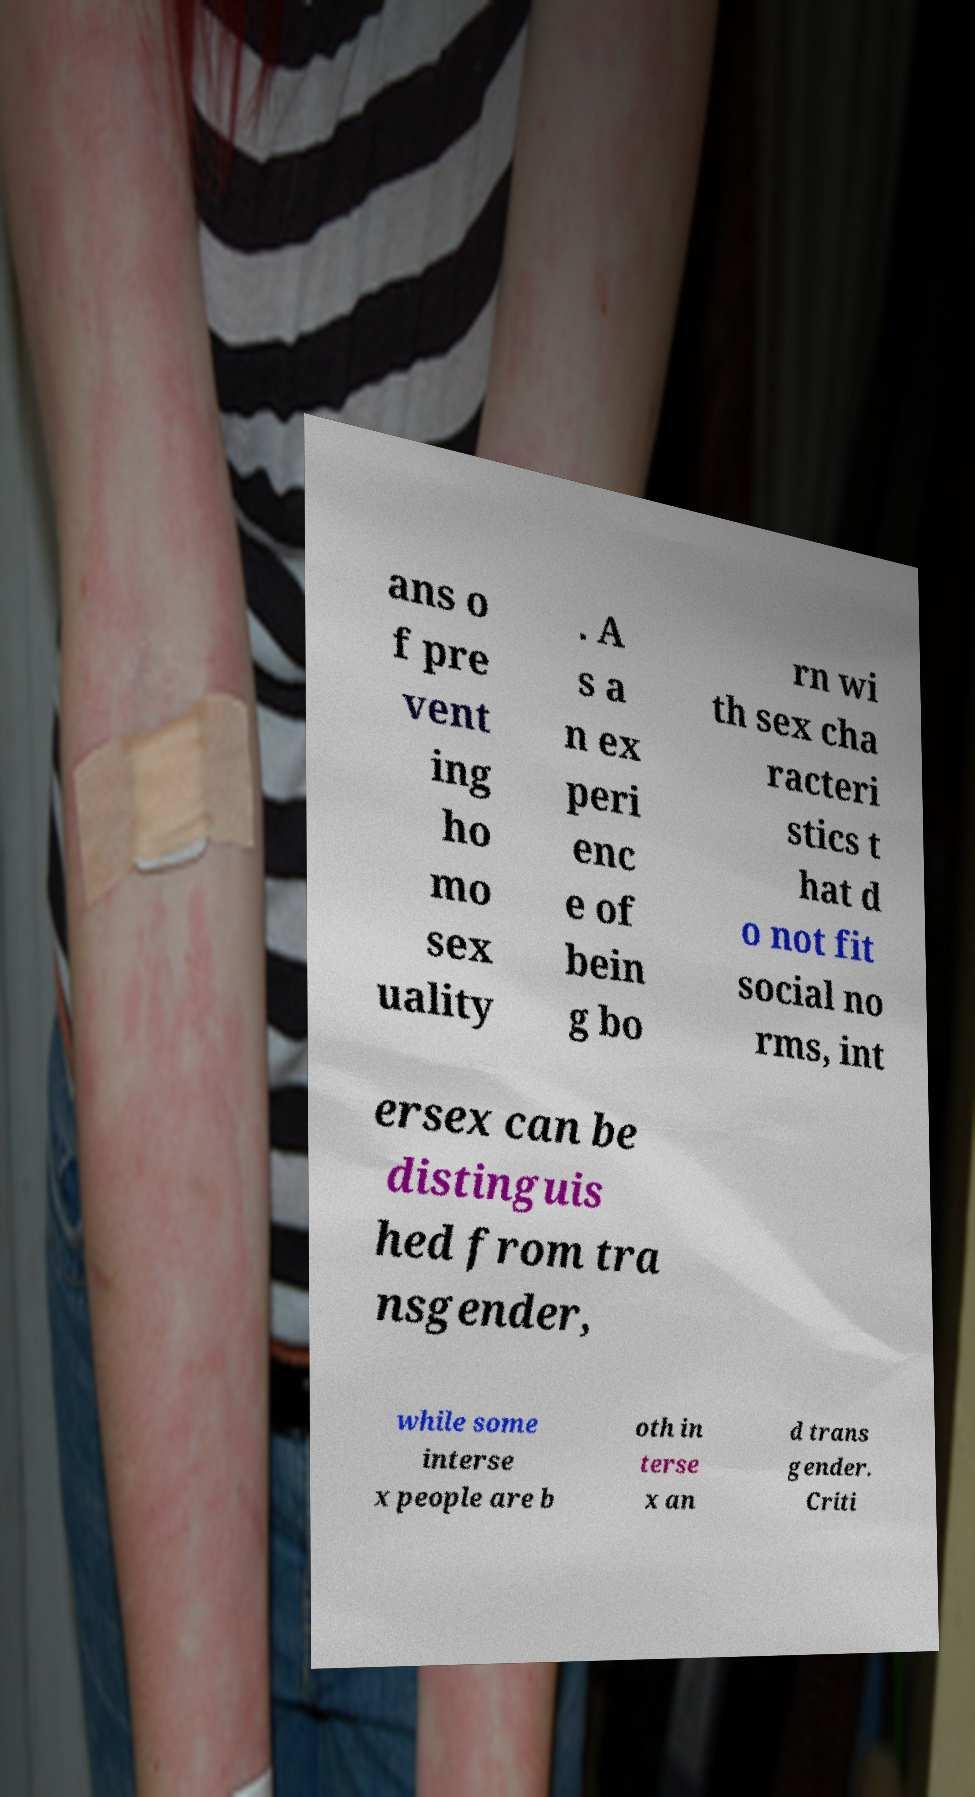Can you read and provide the text displayed in the image?This photo seems to have some interesting text. Can you extract and type it out for me? ans o f pre vent ing ho mo sex uality . A s a n ex peri enc e of bein g bo rn wi th sex cha racteri stics t hat d o not fit social no rms, int ersex can be distinguis hed from tra nsgender, while some interse x people are b oth in terse x an d trans gender. Criti 